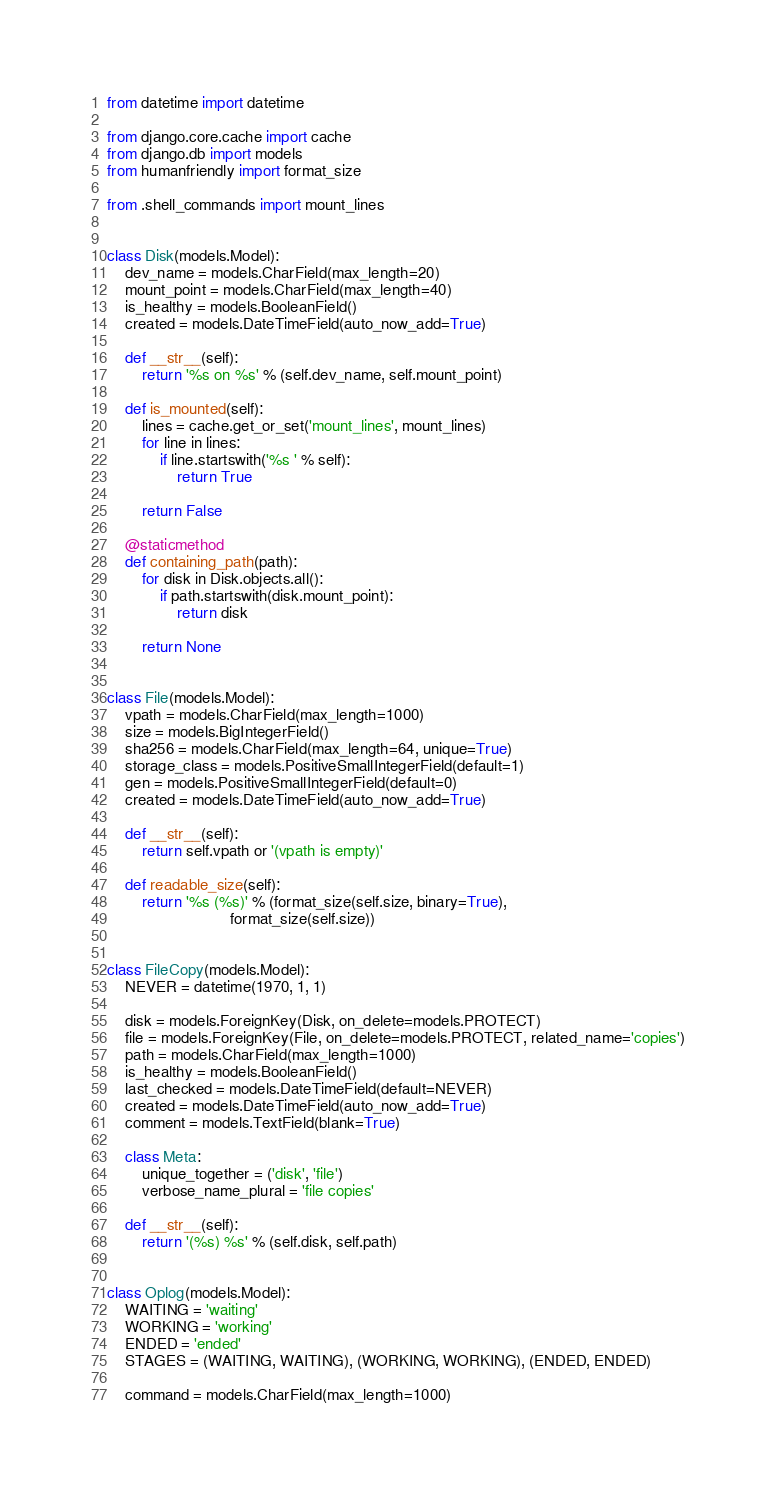Convert code to text. <code><loc_0><loc_0><loc_500><loc_500><_Python_>from datetime import datetime

from django.core.cache import cache
from django.db import models
from humanfriendly import format_size

from .shell_commands import mount_lines


class Disk(models.Model):
    dev_name = models.CharField(max_length=20)
    mount_point = models.CharField(max_length=40)
    is_healthy = models.BooleanField()
    created = models.DateTimeField(auto_now_add=True)

    def __str__(self):
        return '%s on %s' % (self.dev_name, self.mount_point)

    def is_mounted(self):
        lines = cache.get_or_set('mount_lines', mount_lines)
        for line in lines:
            if line.startswith('%s ' % self):
                return True

        return False

    @staticmethod
    def containing_path(path):
        for disk in Disk.objects.all():
            if path.startswith(disk.mount_point):
                return disk

        return None


class File(models.Model):
    vpath = models.CharField(max_length=1000)
    size = models.BigIntegerField()
    sha256 = models.CharField(max_length=64, unique=True)
    storage_class = models.PositiveSmallIntegerField(default=1)
    gen = models.PositiveSmallIntegerField(default=0)
    created = models.DateTimeField(auto_now_add=True)

    def __str__(self):
        return self.vpath or '(vpath is empty)'

    def readable_size(self):
        return '%s (%s)' % (format_size(self.size, binary=True),
                            format_size(self.size))


class FileCopy(models.Model):
    NEVER = datetime(1970, 1, 1)

    disk = models.ForeignKey(Disk, on_delete=models.PROTECT)
    file = models.ForeignKey(File, on_delete=models.PROTECT, related_name='copies')
    path = models.CharField(max_length=1000)
    is_healthy = models.BooleanField()
    last_checked = models.DateTimeField(default=NEVER)
    created = models.DateTimeField(auto_now_add=True)
    comment = models.TextField(blank=True)

    class Meta:
        unique_together = ('disk', 'file')
        verbose_name_plural = 'file copies'

    def __str__(self):
        return '(%s) %s' % (self.disk, self.path)


class Oplog(models.Model):
    WAITING = 'waiting'
    WORKING = 'working'
    ENDED = 'ended'
    STAGES = (WAITING, WAITING), (WORKING, WORKING), (ENDED, ENDED)

    command = models.CharField(max_length=1000)</code> 